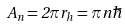Convert formula to latex. <formula><loc_0><loc_0><loc_500><loc_500>A _ { n } = 2 \pi r _ { h } = \pi n \hbar</formula> 